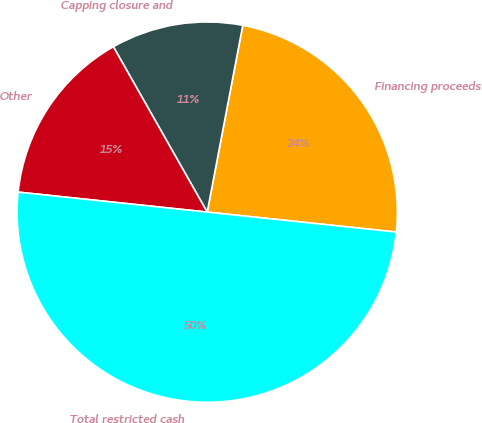<chart> <loc_0><loc_0><loc_500><loc_500><pie_chart><fcel>Financing proceeds<fcel>Capping closure and<fcel>Other<fcel>Total restricted cash<nl><fcel>23.68%<fcel>11.21%<fcel>15.11%<fcel>50.0%<nl></chart> 